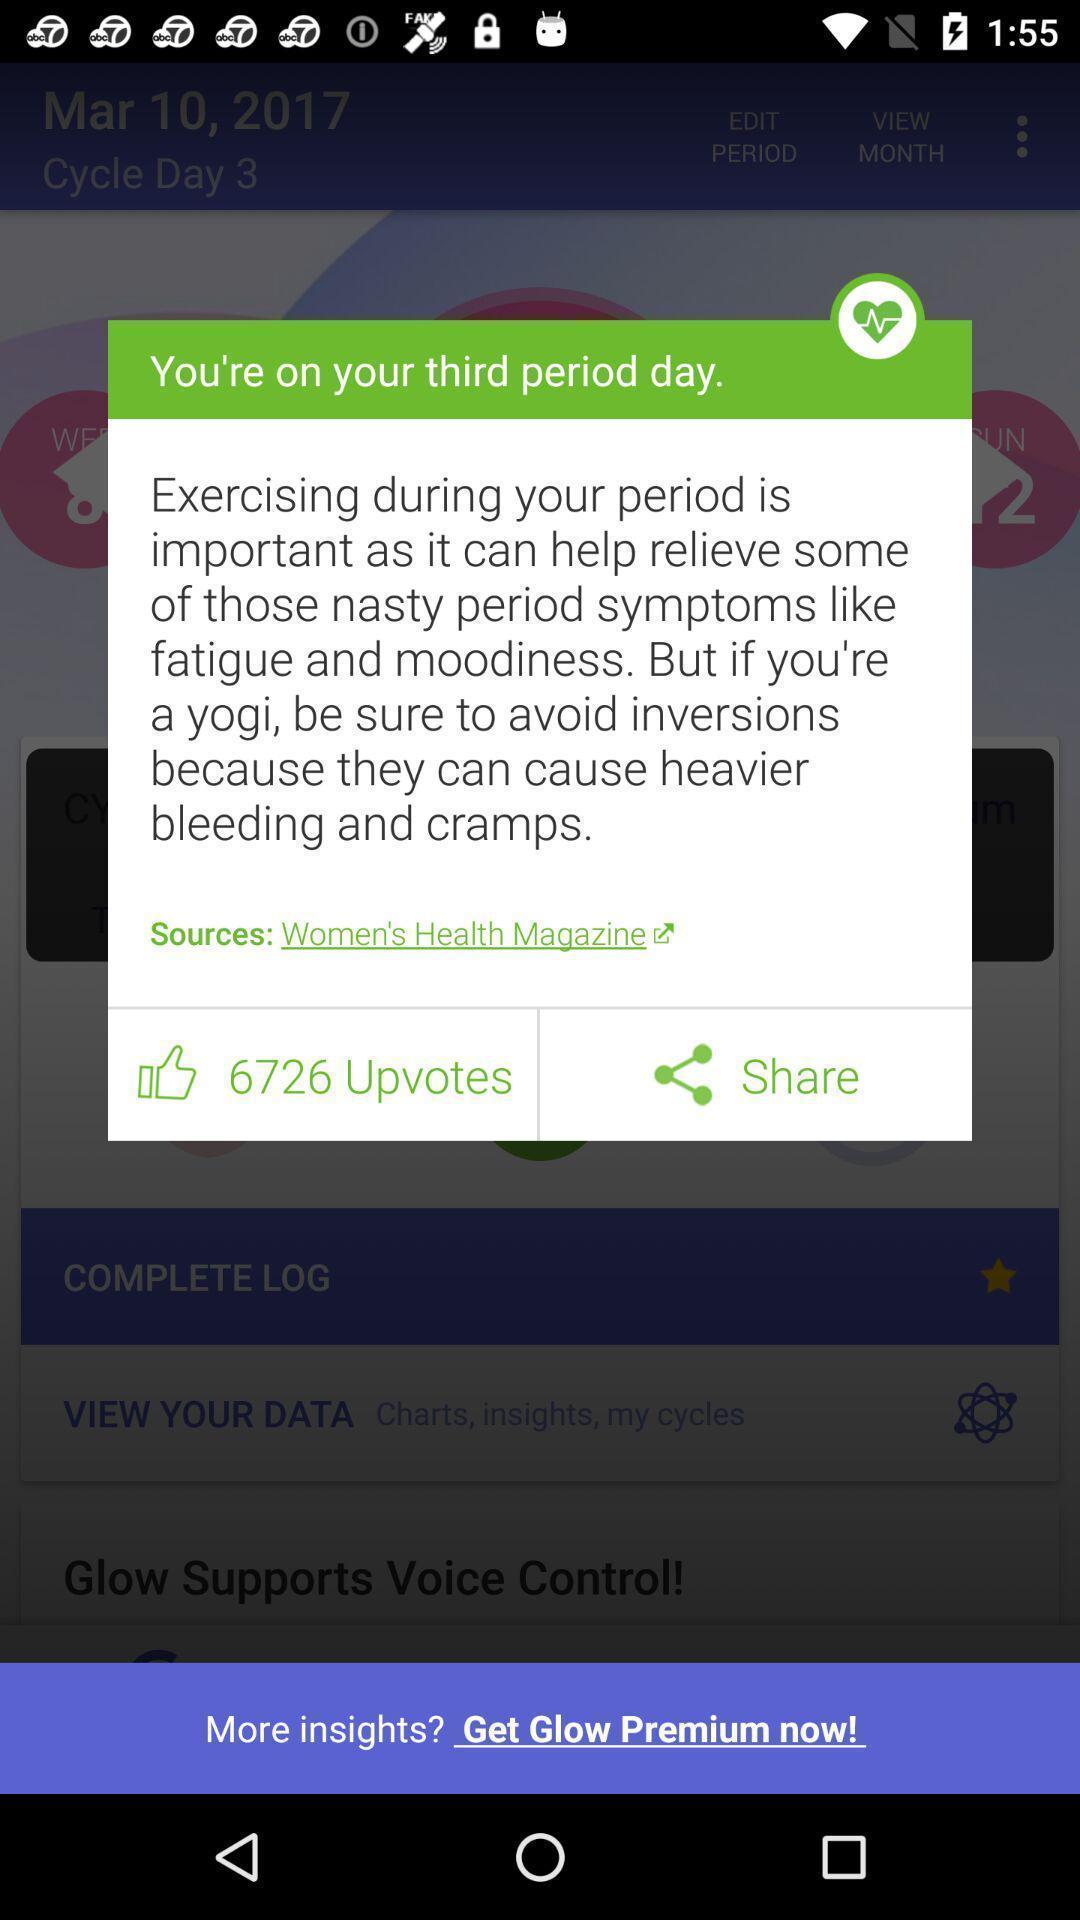Explain what's happening in this screen capture. Pop-up shows a text message about tips for period days. 